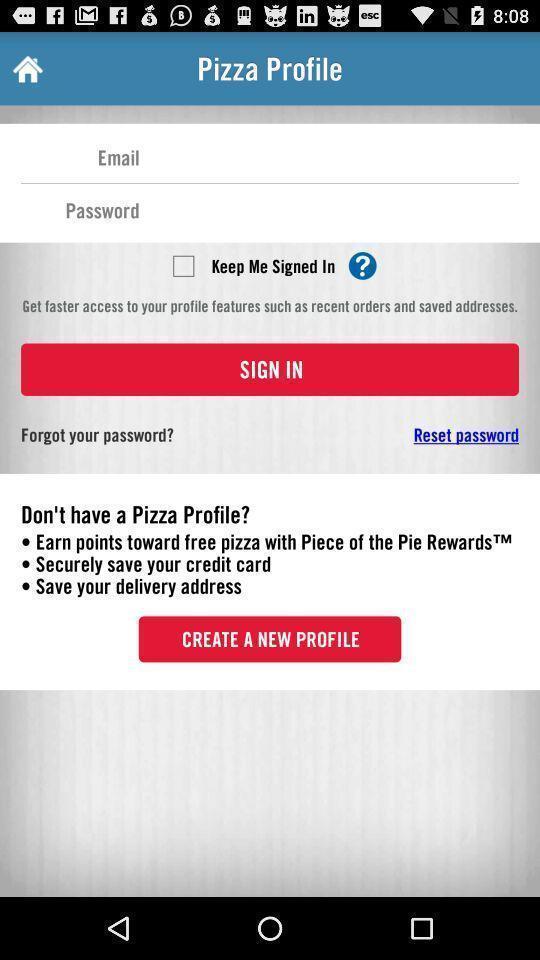Summarize the main components in this picture. Signin page in a food delivery app. 